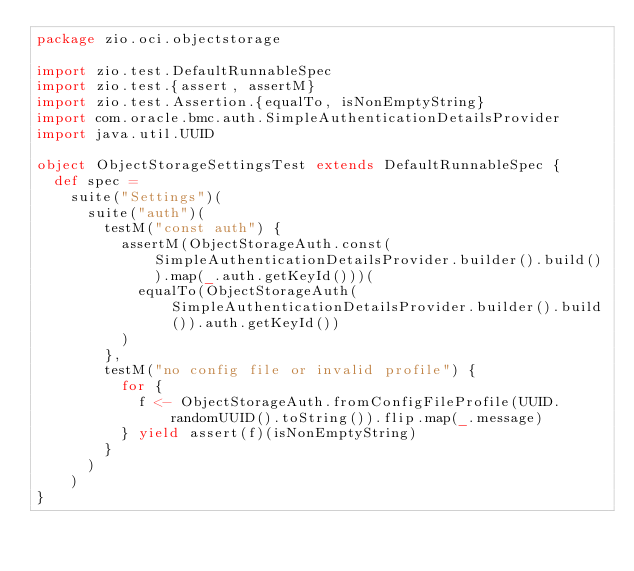Convert code to text. <code><loc_0><loc_0><loc_500><loc_500><_Scala_>package zio.oci.objectstorage

import zio.test.DefaultRunnableSpec
import zio.test.{assert, assertM}
import zio.test.Assertion.{equalTo, isNonEmptyString}
import com.oracle.bmc.auth.SimpleAuthenticationDetailsProvider
import java.util.UUID

object ObjectStorageSettingsTest extends DefaultRunnableSpec {
  def spec =
    suite("Settings")(
      suite("auth")(
        testM("const auth") {
          assertM(ObjectStorageAuth.const(SimpleAuthenticationDetailsProvider.builder().build()).map(_.auth.getKeyId()))(
            equalTo(ObjectStorageAuth(SimpleAuthenticationDetailsProvider.builder().build()).auth.getKeyId())
          )
        },
        testM("no config file or invalid profile") {
          for {
            f <- ObjectStorageAuth.fromConfigFileProfile(UUID.randomUUID().toString()).flip.map(_.message)
          } yield assert(f)(isNonEmptyString)
        }
      )
    )
}
</code> 